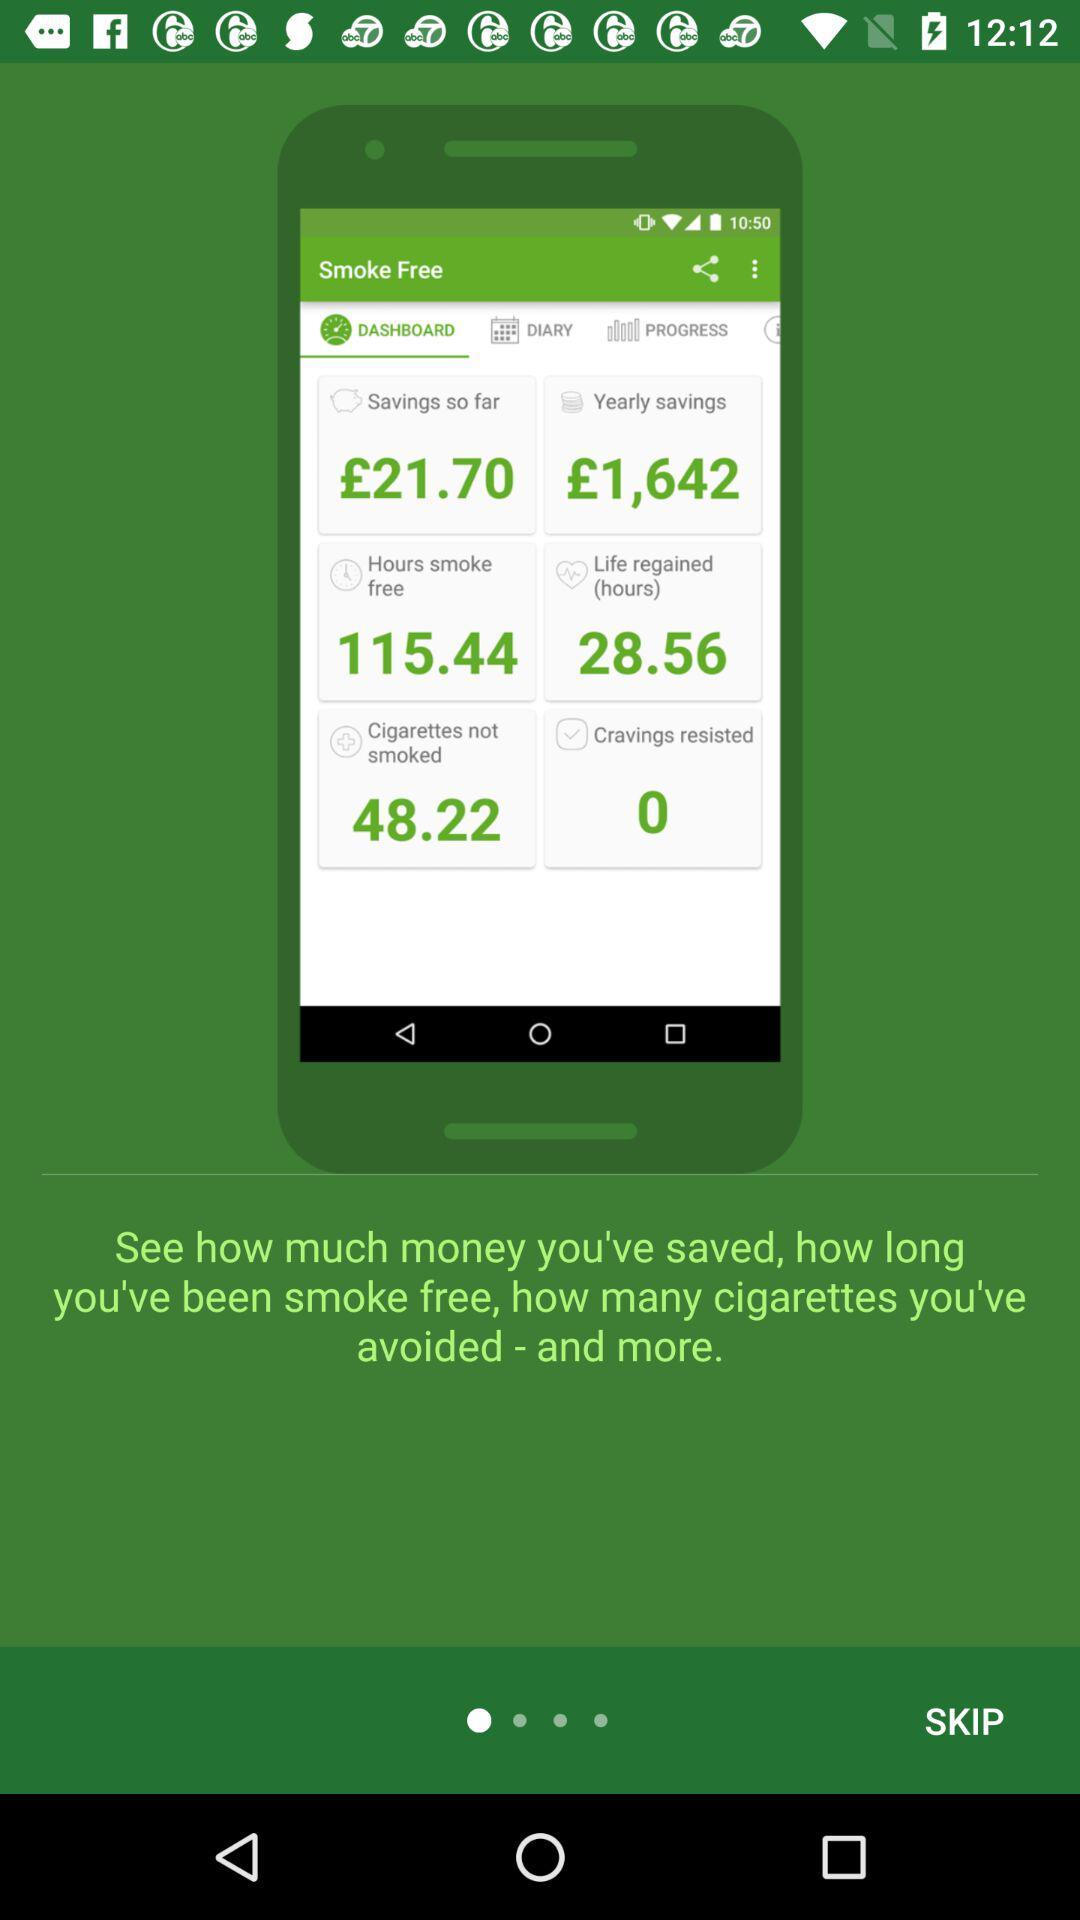How many hours are regained in life? The hours are 28.56. 